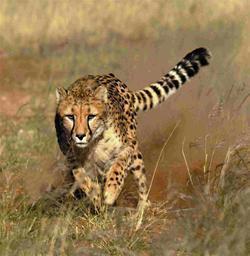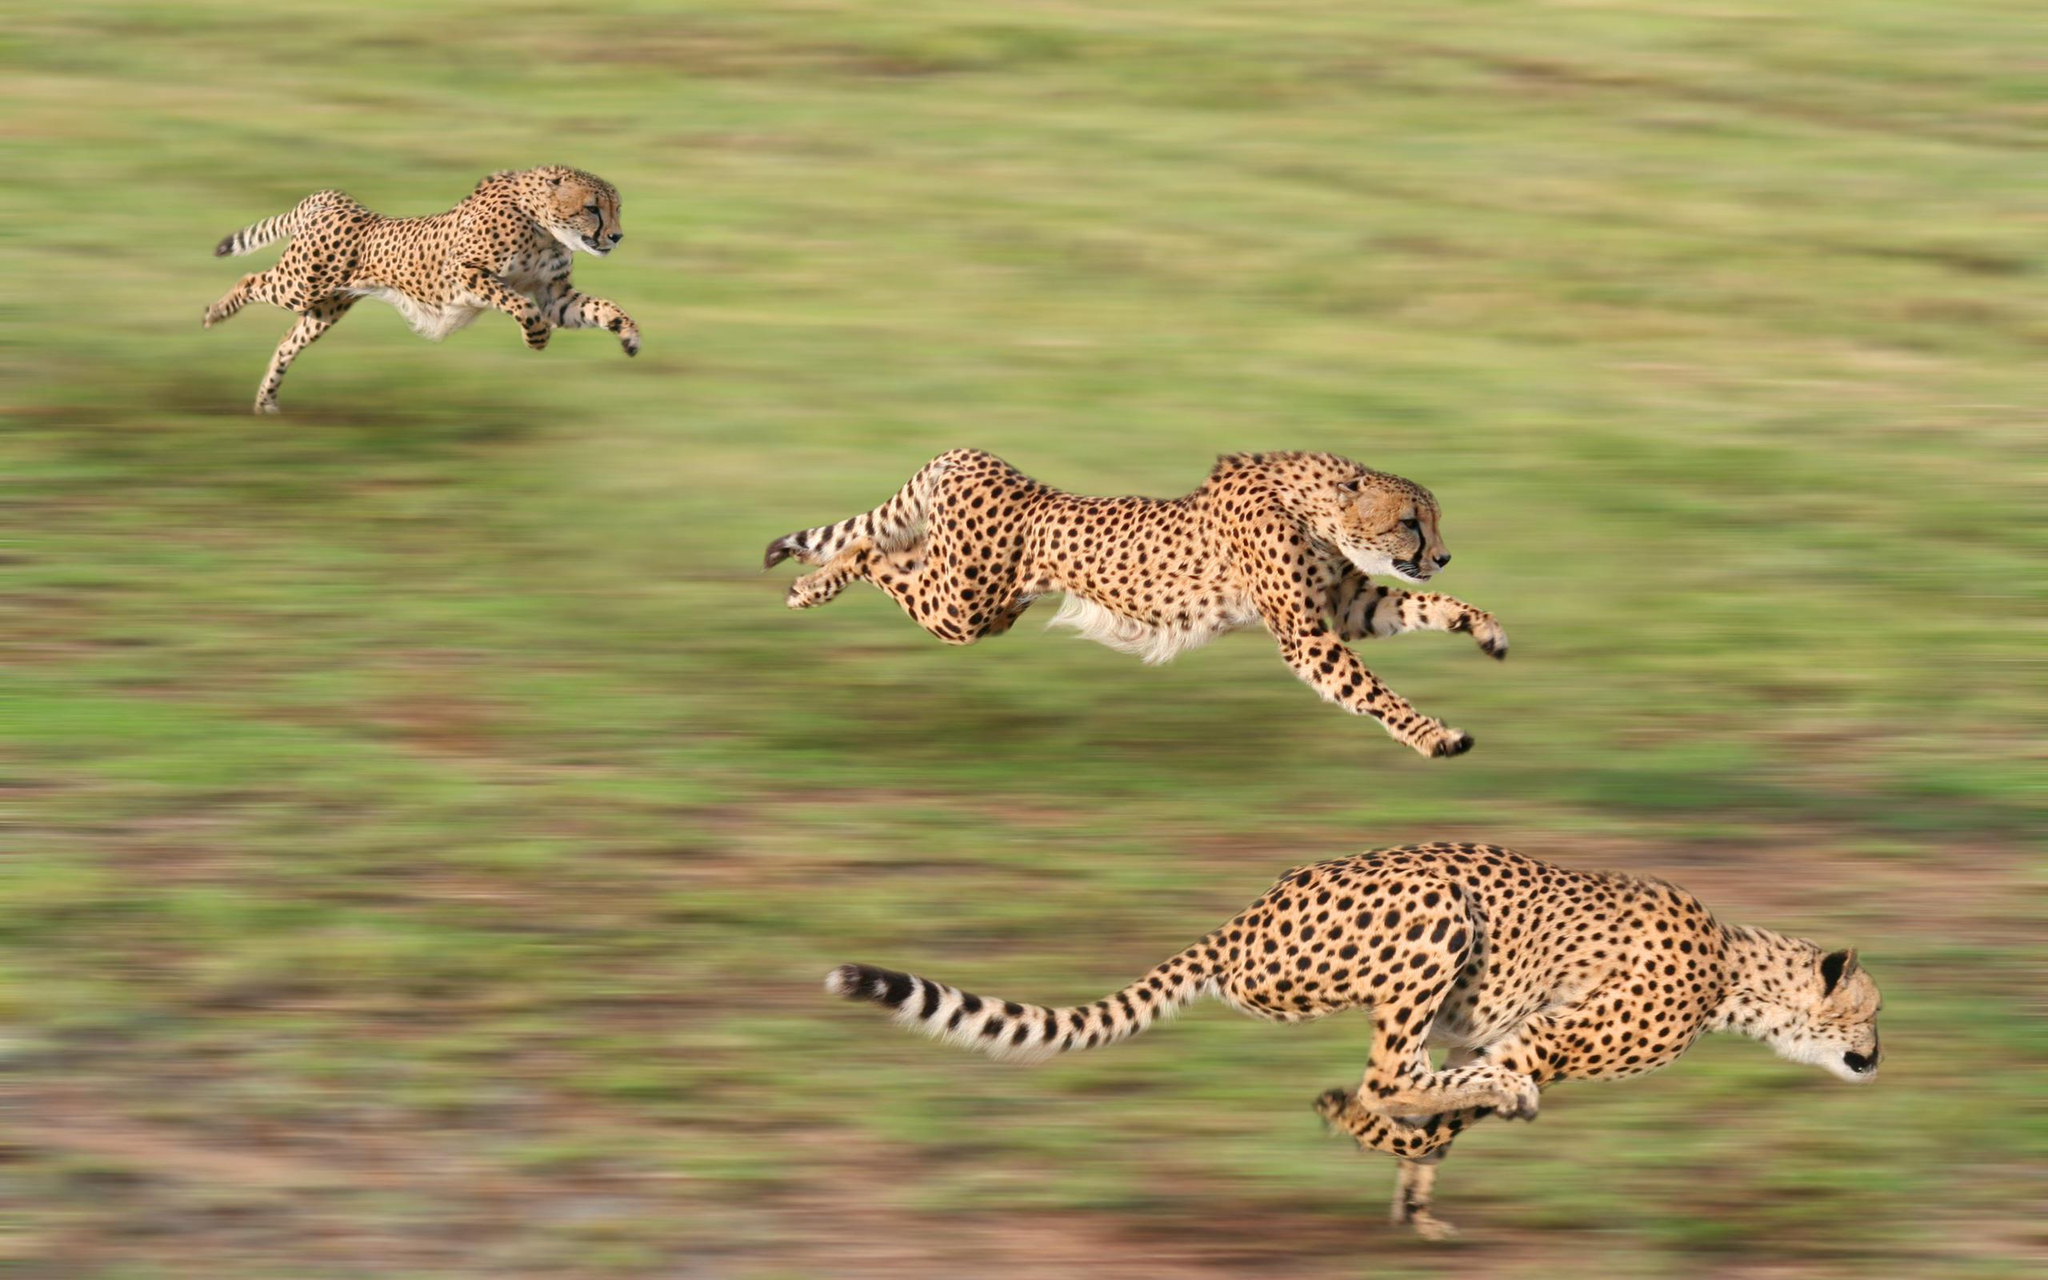The first image is the image on the left, the second image is the image on the right. Assess this claim about the two images: "One image features one cheetah bounding forward.". Correct or not? Answer yes or no. Yes. 